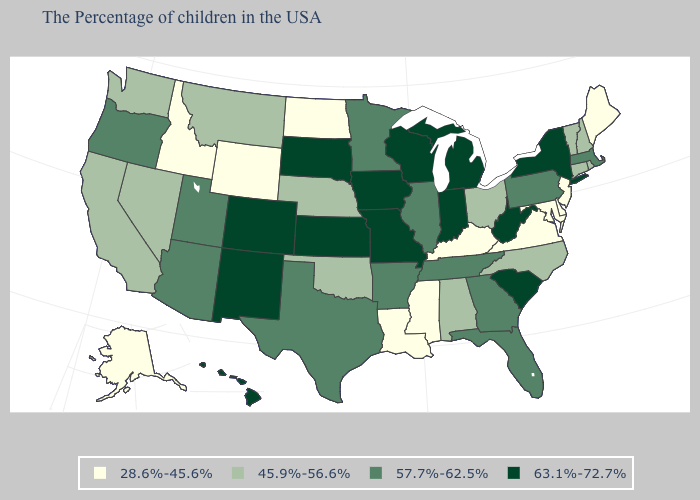How many symbols are there in the legend?
Keep it brief. 4. Does Montana have the lowest value in the West?
Keep it brief. No. Which states have the lowest value in the South?
Write a very short answer. Delaware, Maryland, Virginia, Kentucky, Mississippi, Louisiana. Which states hav the highest value in the West?
Short answer required. Colorado, New Mexico, Hawaii. What is the value of Oregon?
Concise answer only. 57.7%-62.5%. Does Montana have a higher value than Oregon?
Be succinct. No. Among the states that border Arizona , which have the highest value?
Concise answer only. Colorado, New Mexico. How many symbols are there in the legend?
Short answer required. 4. Name the states that have a value in the range 57.7%-62.5%?
Quick response, please. Massachusetts, Pennsylvania, Florida, Georgia, Tennessee, Illinois, Arkansas, Minnesota, Texas, Utah, Arizona, Oregon. Among the states that border South Dakota , which have the highest value?
Quick response, please. Iowa. Which states have the lowest value in the West?
Quick response, please. Wyoming, Idaho, Alaska. What is the highest value in the USA?
Give a very brief answer. 63.1%-72.7%. What is the lowest value in states that border New York?
Answer briefly. 28.6%-45.6%. What is the highest value in the USA?
Short answer required. 63.1%-72.7%. What is the value of New Hampshire?
Give a very brief answer. 45.9%-56.6%. 